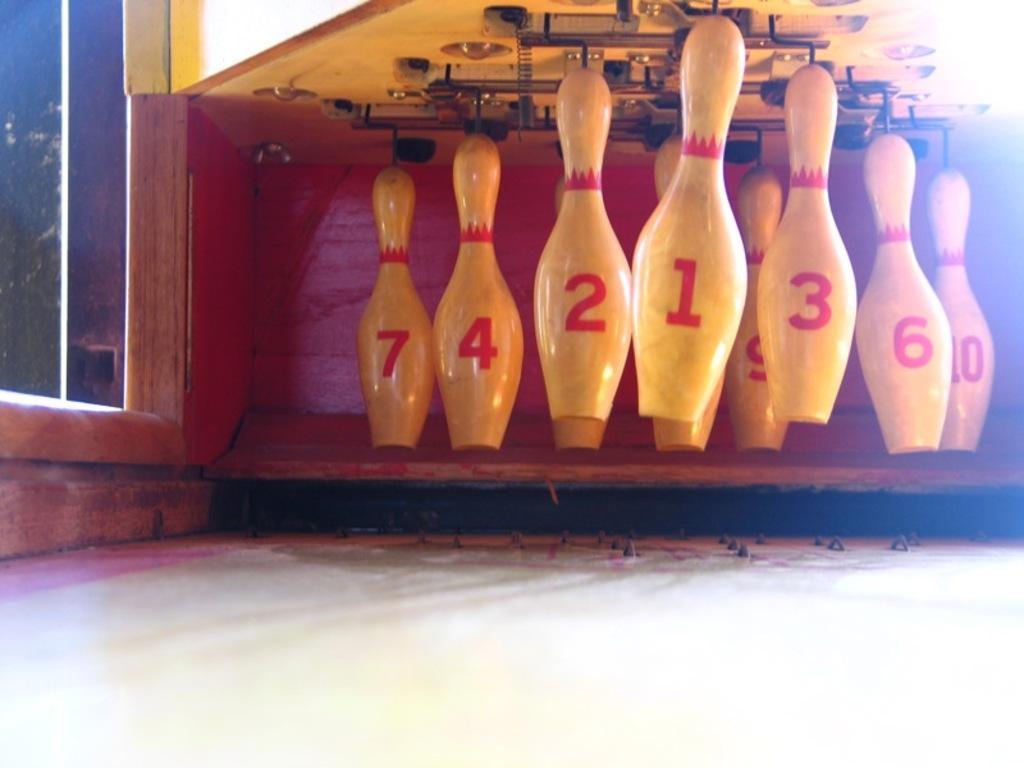In one or two sentences, can you explain what this image depicts? In this image I can see few bowling pins which are in cream color. In-front of the pins I can see the white color surface. To the left there is a glass. 